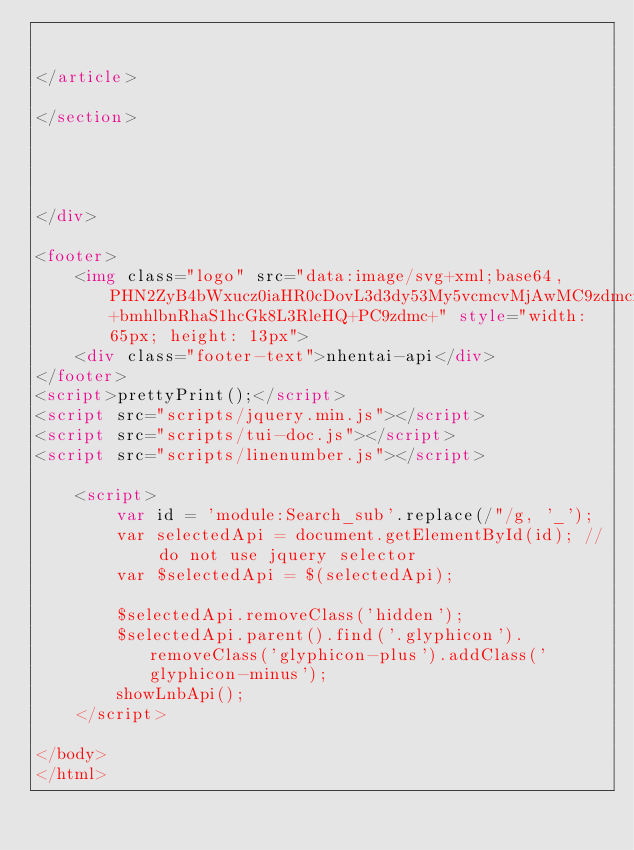<code> <loc_0><loc_0><loc_500><loc_500><_HTML_>
    
</article>

</section>




</div>

<footer>
    <img class="logo" src="data:image/svg+xml;base64,PHN2ZyB4bWxucz0iaHR0cDovL3d3dy53My5vcmcvMjAwMC9zdmciIHZpZXdCb3g9IjAgMCAzMCA1Ij48dGV4dCB4bWxucz0iaHR0cDovL3d3dy53My5vcmcvMjAwMC9zdmciIHg9IjAiIHk9IjEwMCUiIGZpbGw9IndoaXRlIiB0ZXh0TGVuZ3RoPSIzMCIgZm9udC1zaXplPSI1IiBmb250LWZhbWlseT0ic2Fucy1zZXJpZiIgc3R5bGU9InRleHQtdHJhbnNmb3JtOnVwcGVyY2FzZSI+bmhlbnRhaS1hcGk8L3RleHQ+PC9zdmc+" style="width: 65px; height: 13px">
    <div class="footer-text">nhentai-api</div>
</footer>
<script>prettyPrint();</script>
<script src="scripts/jquery.min.js"></script>
<script src="scripts/tui-doc.js"></script>
<script src="scripts/linenumber.js"></script>

    <script>
        var id = 'module:Search_sub'.replace(/"/g, '_');
        var selectedApi = document.getElementById(id); // do not use jquery selector
        var $selectedApi = $(selectedApi);

        $selectedApi.removeClass('hidden');
        $selectedApi.parent().find('.glyphicon').removeClass('glyphicon-plus').addClass('glyphicon-minus');
        showLnbApi();
    </script>

</body>
</html></code> 